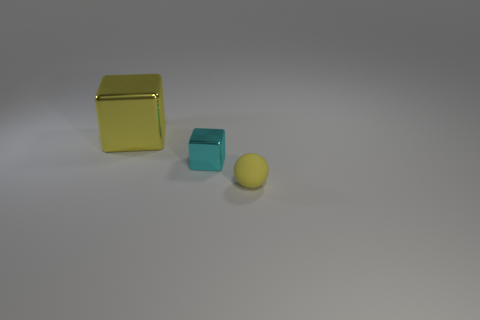Add 1 yellow cubes. How many objects exist? 4 Subtract all balls. How many objects are left? 2 Subtract 0 red balls. How many objects are left? 3 Subtract all big yellow metallic cylinders. Subtract all large metal things. How many objects are left? 2 Add 1 cyan blocks. How many cyan blocks are left? 2 Add 1 large cyan matte cylinders. How many large cyan matte cylinders exist? 1 